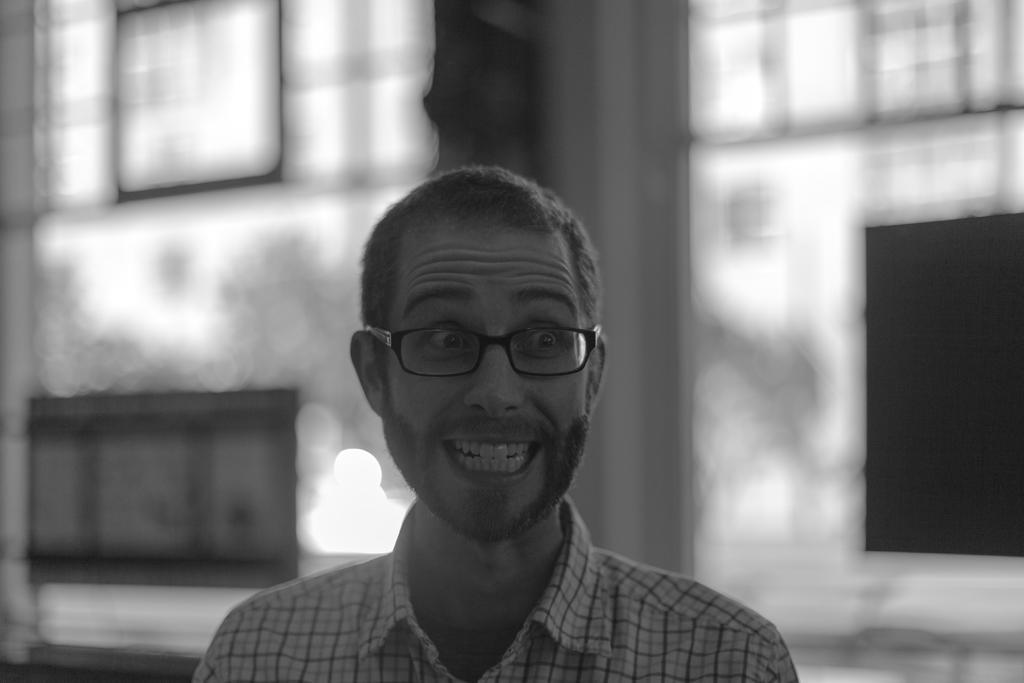Could you give a brief overview of what you see in this image? There is a man wore spectacle. In the background it is blur. 